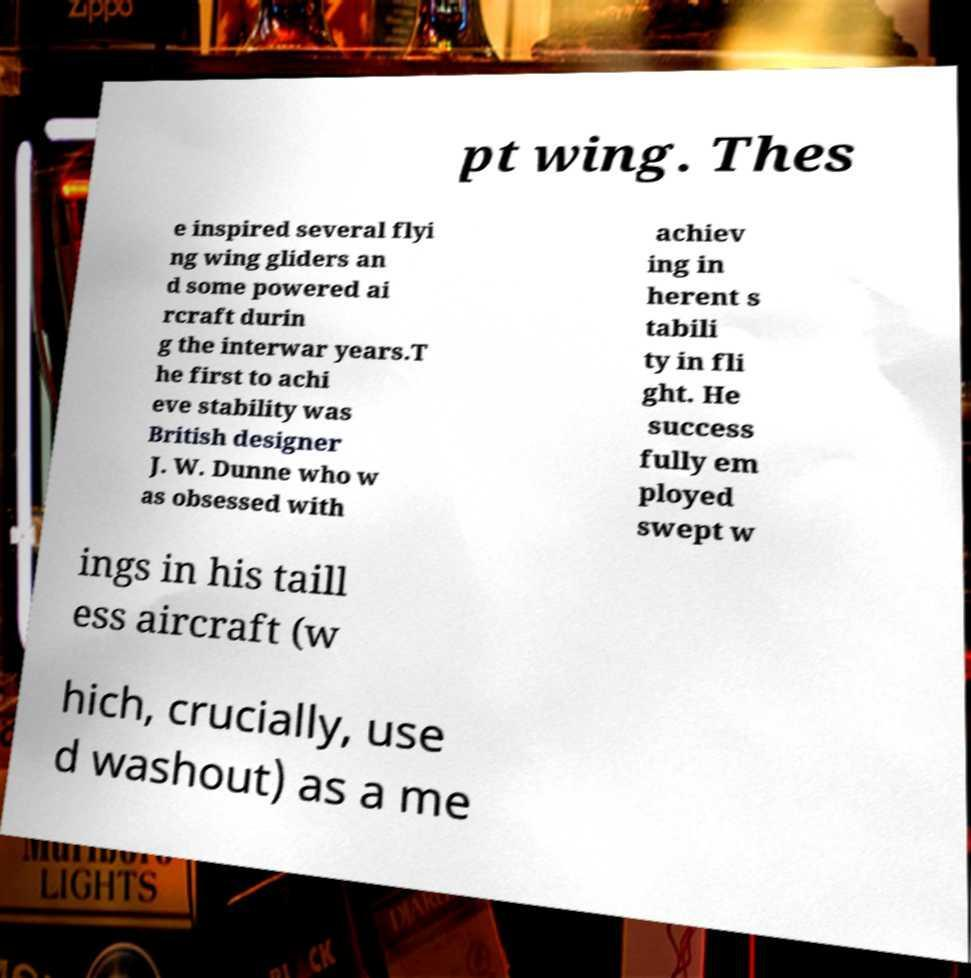What messages or text are displayed in this image? I need them in a readable, typed format. pt wing. Thes e inspired several flyi ng wing gliders an d some powered ai rcraft durin g the interwar years.T he first to achi eve stability was British designer J. W. Dunne who w as obsessed with achiev ing in herent s tabili ty in fli ght. He success fully em ployed swept w ings in his taill ess aircraft (w hich, crucially, use d washout) as a me 